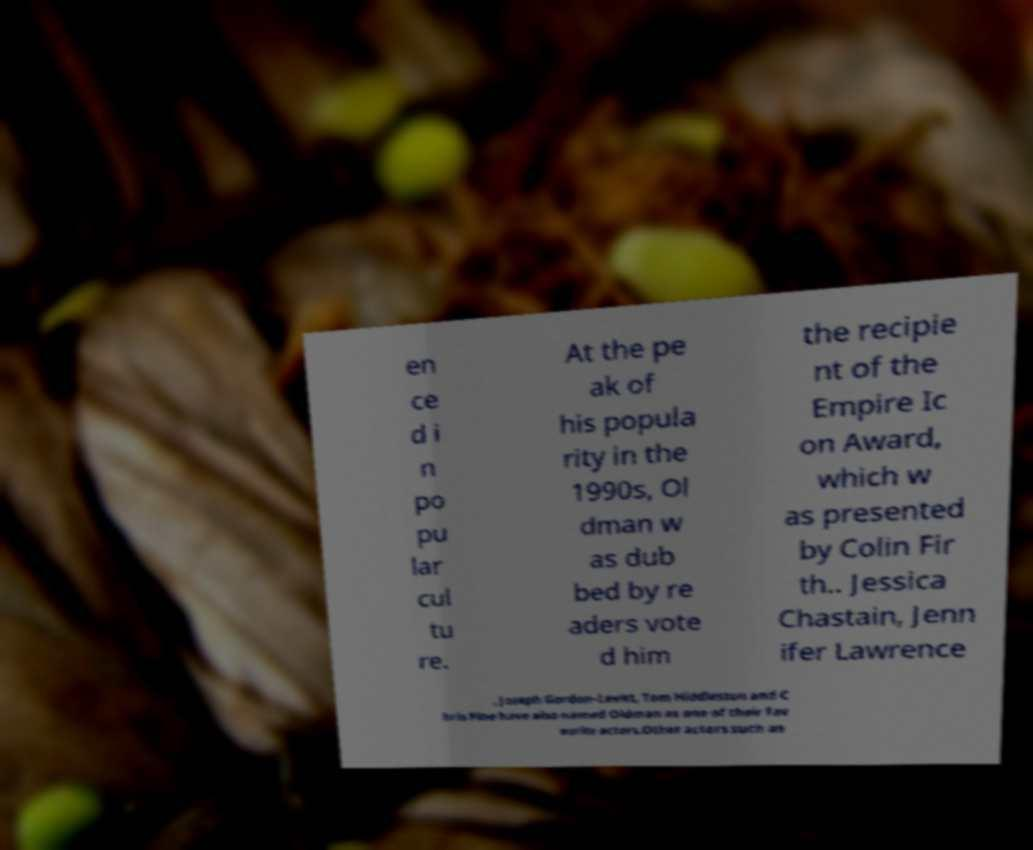Can you read and provide the text displayed in the image?This photo seems to have some interesting text. Can you extract and type it out for me? en ce d i n po pu lar cul tu re. At the pe ak of his popula rity in the 1990s, Ol dman w as dub bed by re aders vote d him the recipie nt of the Empire Ic on Award, which w as presented by Colin Fir th.. Jessica Chastain, Jenn ifer Lawrence , Joseph Gordon-Levitt, Tom Hiddleston and C hris Pine have also named Oldman as one of their fav ourite actors.Other actors such as 